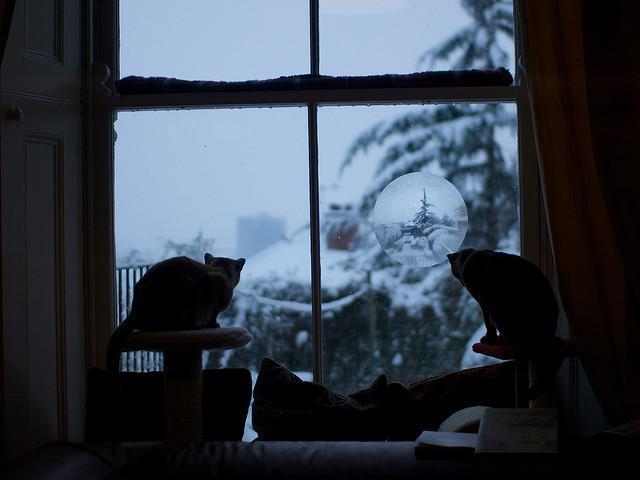How many cats?
Give a very brief answer. 2. How many cats are there?
Give a very brief answer. 2. How many horses are eating grass?
Give a very brief answer. 0. 